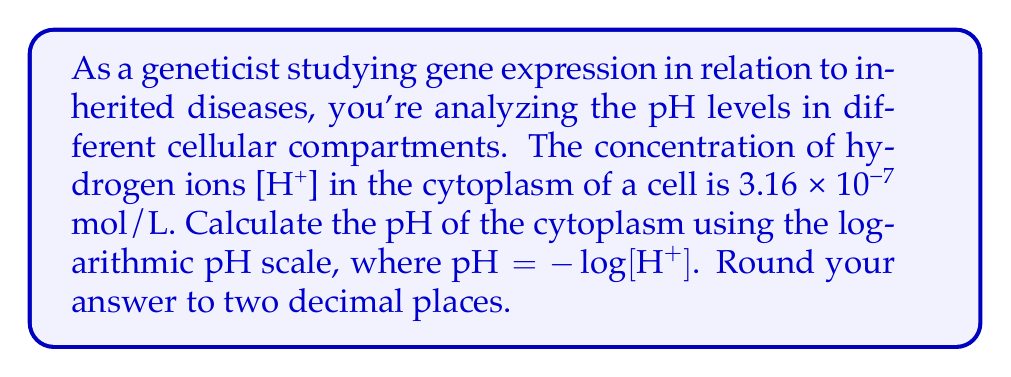Solve this math problem. To solve this problem, we'll use the given formula: $pH = -log[H^+]$

Step 1: Identify the hydrogen ion concentration
[H+] = 3.16 × 10^(-7) mol/L

Step 2: Apply the pH formula
$pH = -log[H^+]$
$pH = -log(3.16 × 10^{-7})$

Step 3: Use the properties of logarithms to simplify
$pH = -log(3.16) - log(10^{-7})$
$pH = -0.4997 + 7$

Step 4: Calculate the result
$pH = 6.5003$

Step 5: Round to two decimal places
pH ≈ 6.50

This pH value indicates that the cytoplasm is slightly acidic, which is typical for cellular environments. Understanding pH levels in different cellular compartments is crucial for studying gene expression, as pH can affect protein folding, enzyme activity, and other cellular processes that influence the manifestation of inherited diseases.
Answer: 6.50 